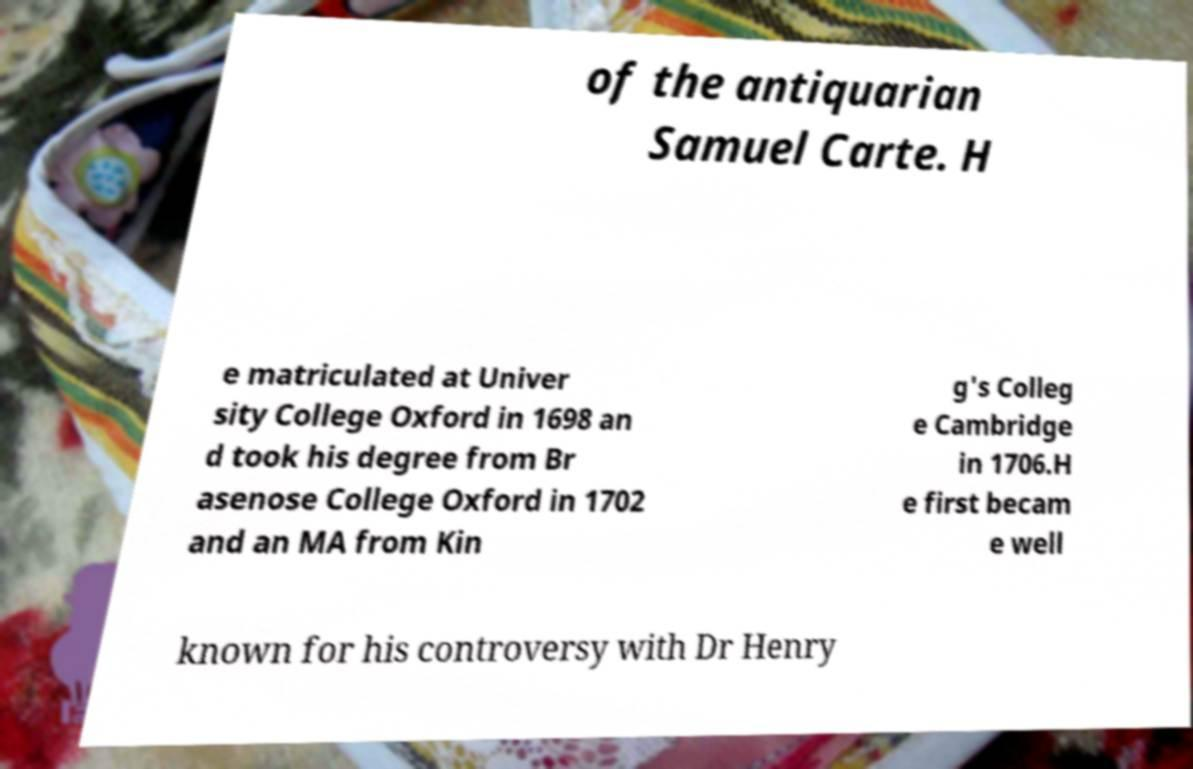Could you extract and type out the text from this image? of the antiquarian Samuel Carte. H e matriculated at Univer sity College Oxford in 1698 an d took his degree from Br asenose College Oxford in 1702 and an MA from Kin g's Colleg e Cambridge in 1706.H e first becam e well known for his controversy with Dr Henry 